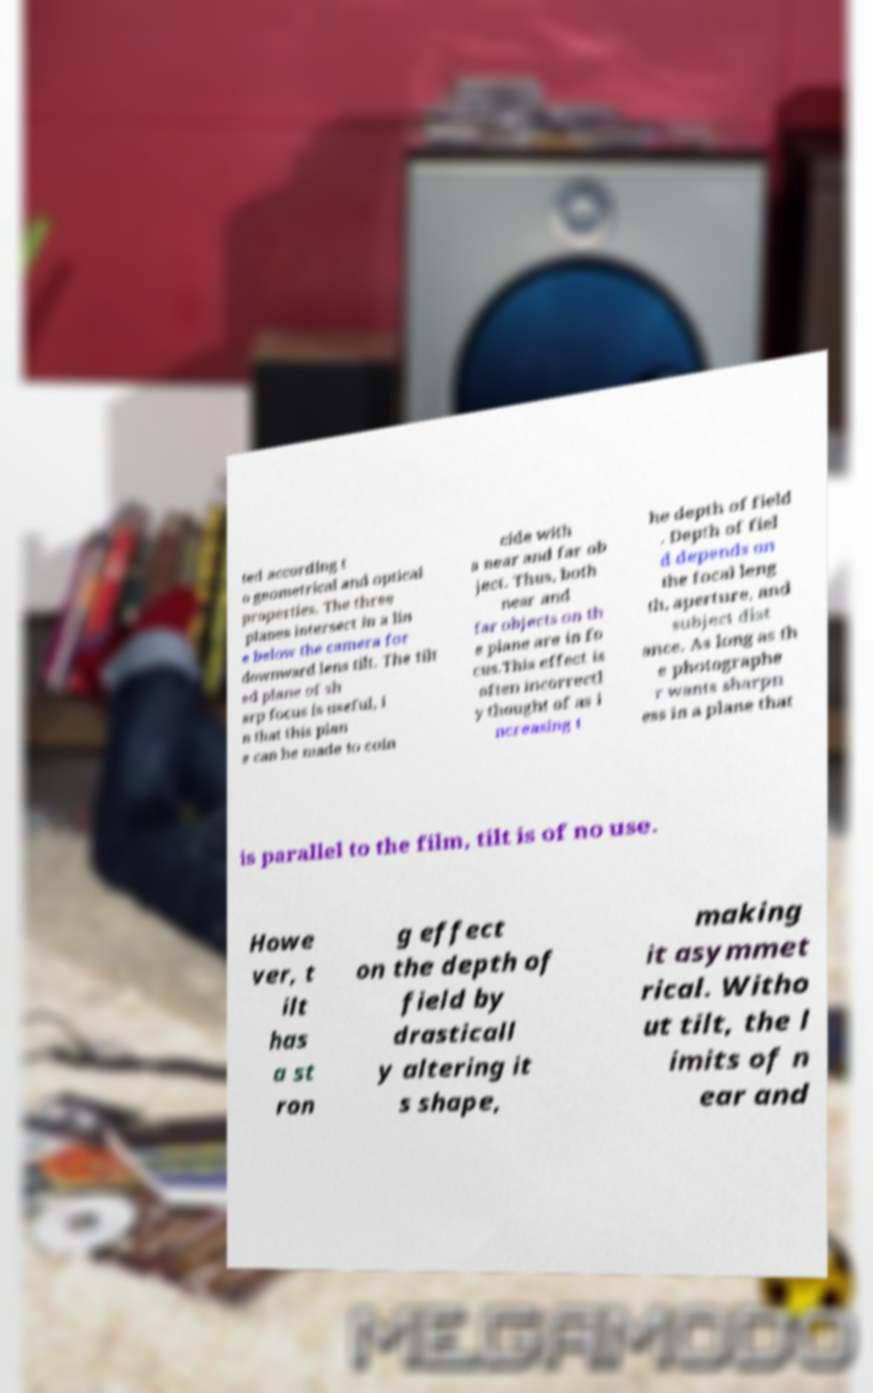What messages or text are displayed in this image? I need them in a readable, typed format. ted according t o geometrical and optical properties. The three planes intersect in a lin e below the camera for downward lens tilt. The tilt ed plane of sh arp focus is useful, i n that this plan e can be made to coin cide with a near and far ob ject. Thus, both near and far objects on th e plane are in fo cus.This effect is often incorrectl y thought of as i ncreasing t he depth of field . Depth of fiel d depends on the focal leng th, aperture, and subject dist ance. As long as th e photographe r wants sharpn ess in a plane that is parallel to the film, tilt is of no use. Howe ver, t ilt has a st ron g effect on the depth of field by drasticall y altering it s shape, making it asymmet rical. Witho ut tilt, the l imits of n ear and 